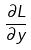Convert formula to latex. <formula><loc_0><loc_0><loc_500><loc_500>\frac { \partial L } { \partial y }</formula> 